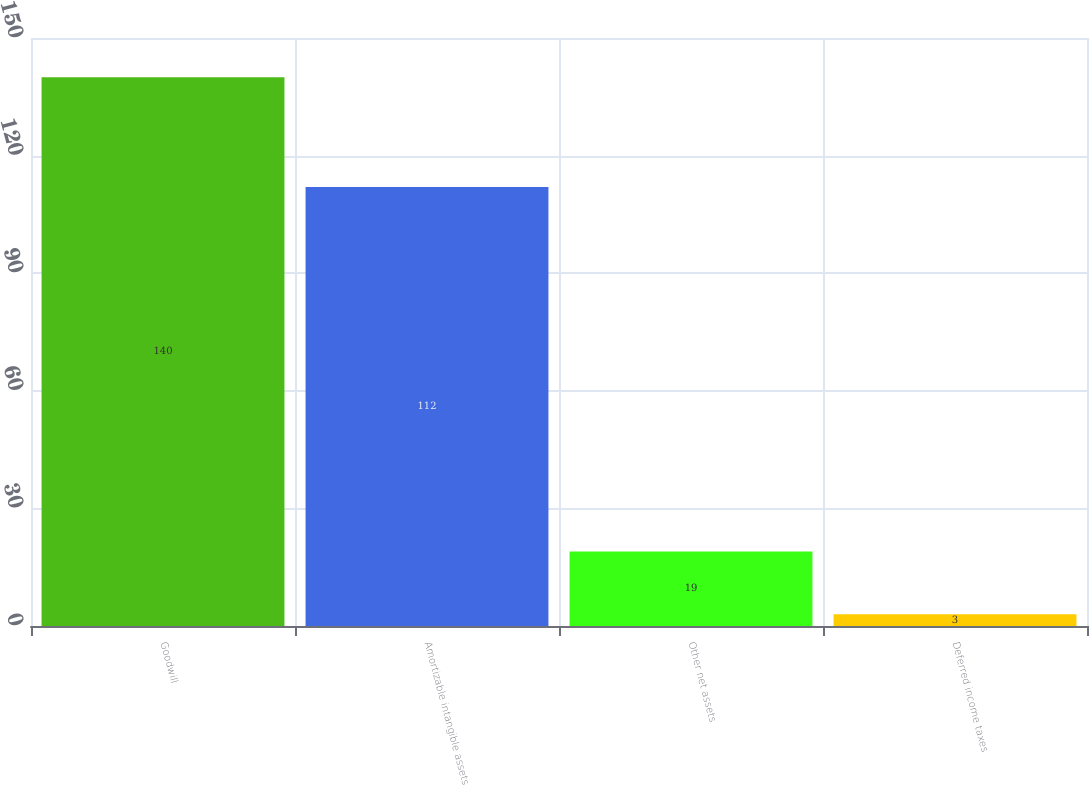Convert chart to OTSL. <chart><loc_0><loc_0><loc_500><loc_500><bar_chart><fcel>Goodwill<fcel>Amortizable intangible assets<fcel>Other net assets<fcel>Deferred income taxes<nl><fcel>140<fcel>112<fcel>19<fcel>3<nl></chart> 